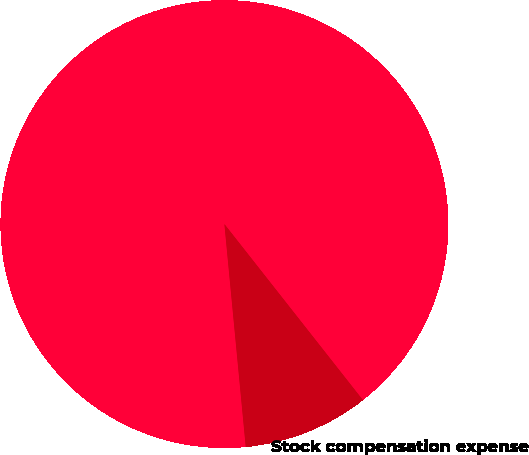Convert chart to OTSL. <chart><loc_0><loc_0><loc_500><loc_500><pie_chart><fcel>Shares issued<fcel>Aggregate purchase price<fcel>Stock compensation expense<nl><fcel>90.91%<fcel>9.09%<fcel>0.0%<nl></chart> 